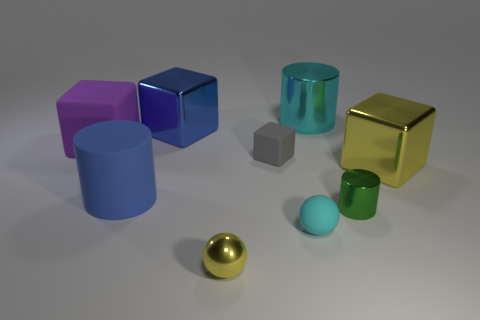What might be the purpose of arranging these objects together? This arrangement might serve as a visual study of shapes, materials, and colors, possibly for artistic or educational purposes. It showcases geometric variety and different color reflections, highlighting how light interacts with surfaces and can be used to explain concepts like reflection, texture, and spatial perception. 